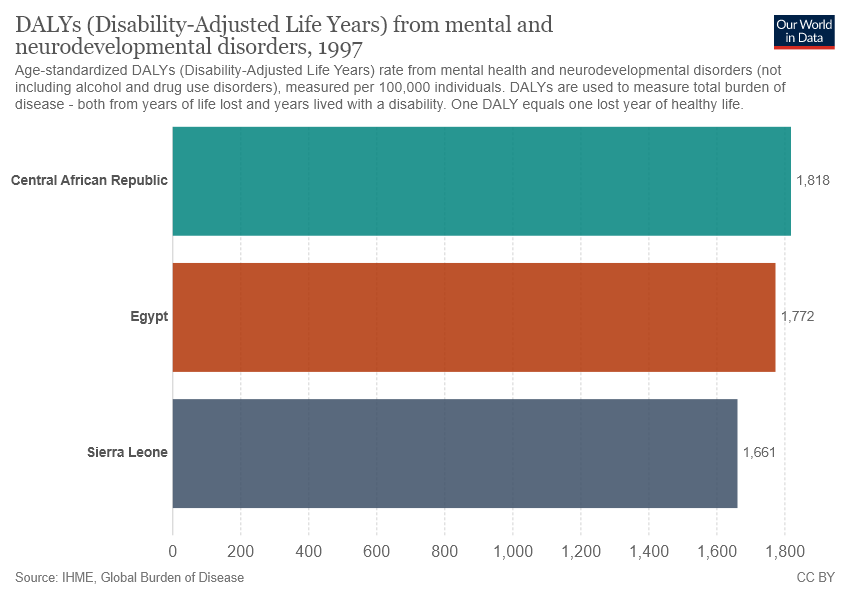Give some essential details in this illustration. Egypt, represented by the brown bar, is the country that was asked about. The value of Egypt and Sierra Leone differ by 111... 